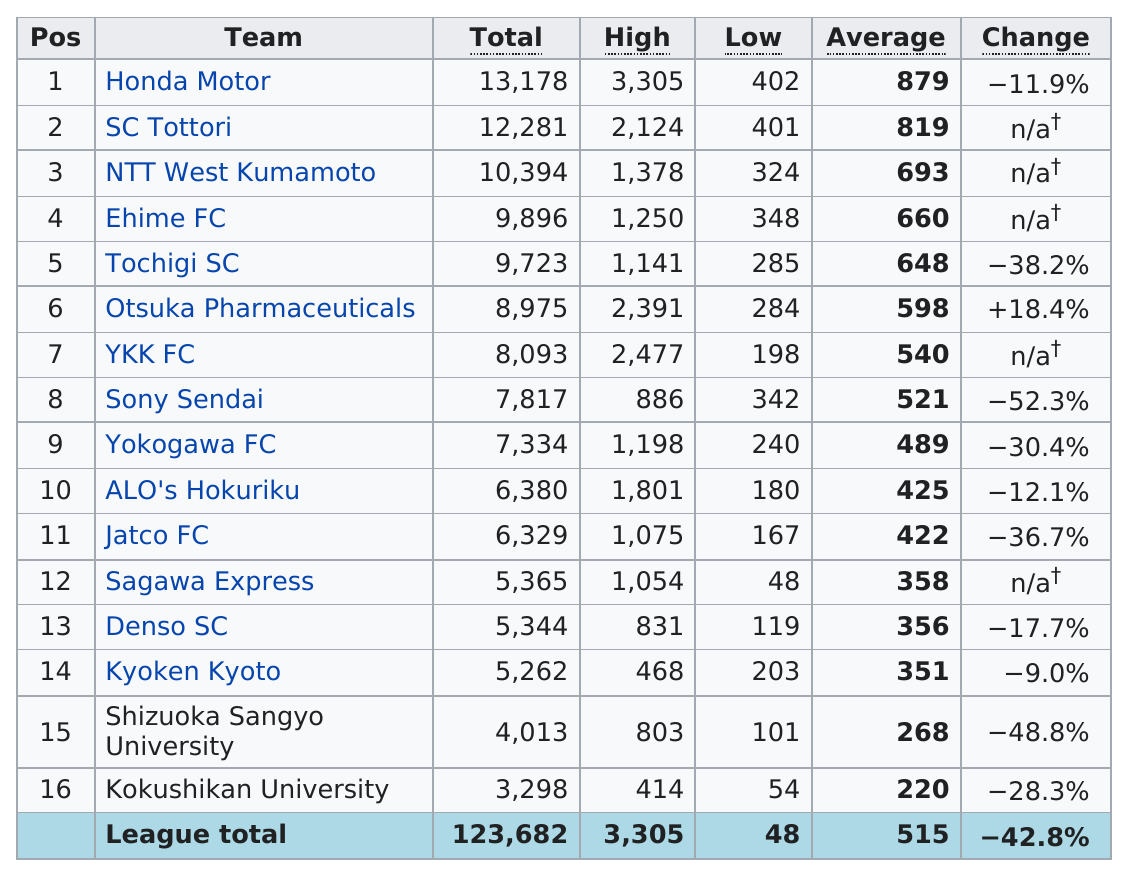List a handful of essential elements in this visual. Kokushikan University's team consistently has the lowest attendance out of all participating teams. Seven teams had a total attendance above 8000. The top five teams with the highest total are: Honda Motor, SC Tottori, NTT West Kumamoto, Ehime FC, and Tochigi SC. The Japanese football league game in 2001 had the highest attendance of 13,178 fans. Honda Motor Company has the highest attendance recorded among all teams. 